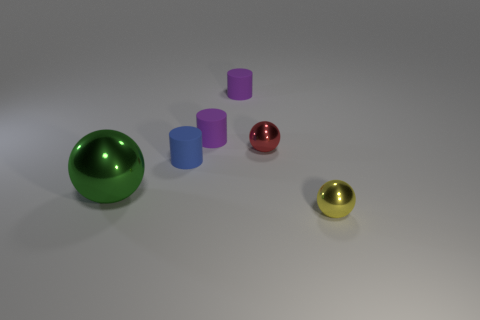Add 2 blue things. How many objects exist? 8 Add 4 tiny matte cylinders. How many tiny matte cylinders are left? 7 Add 3 green metallic balls. How many green metallic balls exist? 4 Subtract 0 blue balls. How many objects are left? 6 Subtract all small yellow things. Subtract all large red metallic balls. How many objects are left? 5 